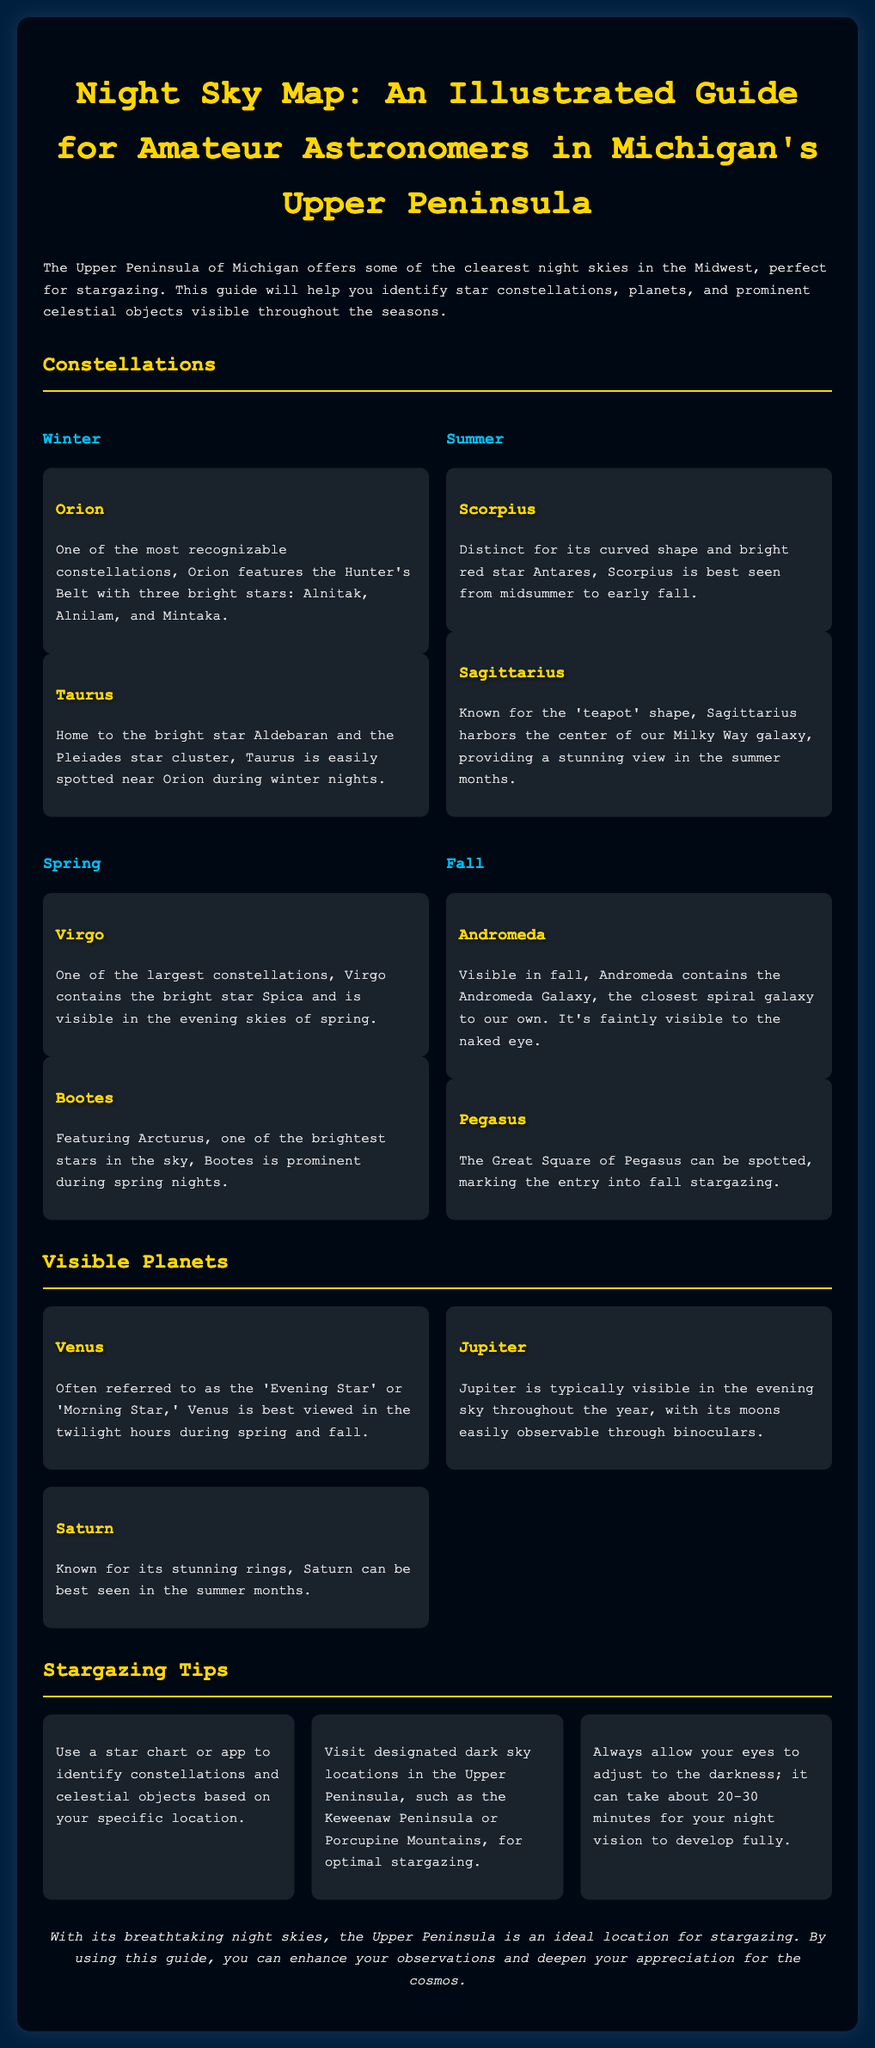What is the title of the guide? The title of the guide is stated at the beginning of the document as "Night Sky Map: An Illustrated Guide for Amateur Astronomers in Michigan's Upper Peninsula."
Answer: Night Sky Map: An Illustrated Guide for Amateur Astronomers in Michigan's Upper Peninsula Which constellation features the Hunter's Belt? The constellation Orion is described as featuring the Hunter's Belt with three bright stars, which identifies it easily.
Answer: Orion In which season is the constellation Scorpius best seen? The document states that Scorpius is best seen from midsummer to early fall, indicating its season of visibility.
Answer: Summer What bright star is associated with the constellation Taurus? The document mentions the bright star Aldebaran as being part of the Taurus constellation.
Answer: Aldebaran List one planet that is referred to as the 'Morning Star.' The document specifically refers to Venus as the 'Morning Star' in the context of its visibility.
Answer: Venus How long does it take for your night vision to develop fully? The document states that it can take about 20-30 minutes for your night vision to develop fully.
Answer: 20-30 minutes What is a recommended location in the Upper Peninsula for stargazing? The guide suggests visiting designated dark sky locations, such as the Keweenaw Peninsula or Porcupine Mountains, for optimal stargazing.
Answer: Keweenaw Peninsula Which constellation contains the Andromeda Galaxy? The document specifies that the constellation Andromeda contains the Andromeda Galaxy.
Answer: Andromeda What is the conclusion of the guide? The conclusion summarizes that the Upper Peninsula is ideal for stargazing and encourages readers to use the guide for greater appreciation of the cosmos.
Answer: Ideal location for stargazing 